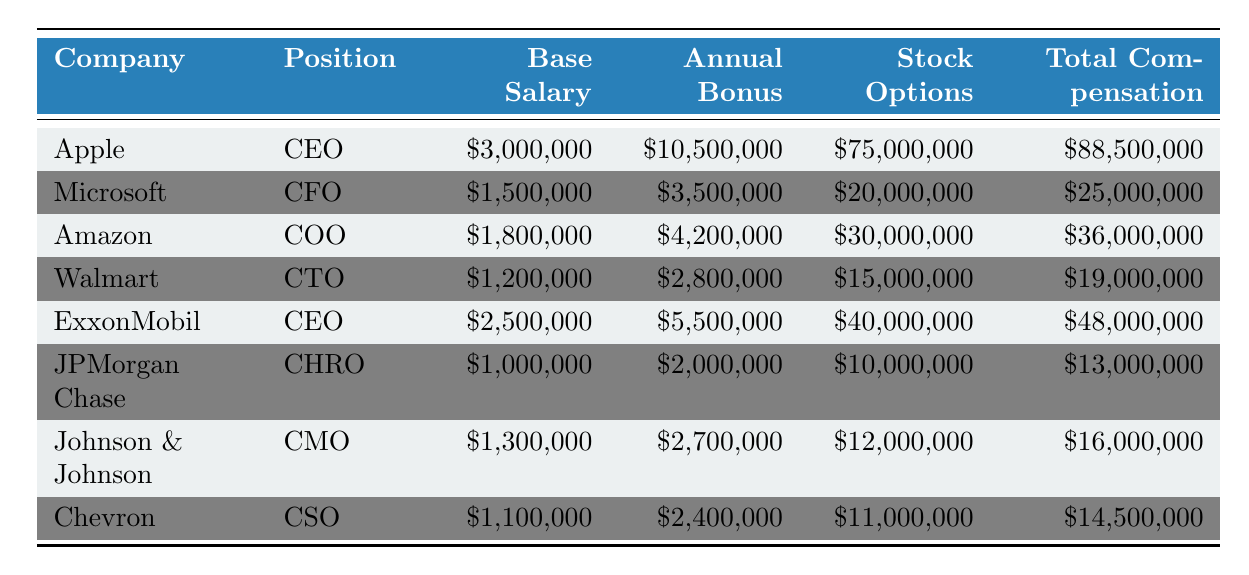What is the total compensation for the CEO of Apple? The table lists the CEO of Apple with a total compensation of $88,500,000.
Answer: $88,500,000 Which executive position has the highest base salary? Reviewing the base salaries, Apple's CEO has the highest at $3,000,000.
Answer: CEO of Apple True or False: The CEO of ExxonMobil has a higher total compensation than the CEO of Apple. The total compensation for the CEO of ExxonMobil is $48,000,000, which is less than Apple's $88,500,000. Thus, the statement is false.
Answer: False What is the average base salary of the executives listed? Adding the base salaries ($3,000,000 + $1,500,000 + $1,800,000 + $1,200,000 + $2,500,000 + $1,000,000 + $1,300,000 + $1,100,000) gives $12,400,000. There are 8 executives, so the average is $12,400,000 / 8 = $1,550,000.
Answer: $1,550,000 Which company offers the least stock options? Looking at the stock options provided, Chevron offers the least at $11,000,000.
Answer: Chevron What is the difference between the total compensation of the CEO of Apple and the CFO of Microsoft? The CEO of Apple has a total compensation of $88,500,000, while the CFO of Microsoft has $25,000,000. The difference is $88,500,000 - $25,000,000 = $63,500,000.
Answer: $63,500,000 True or False: The total compensation for the CHRO of JPMorgan Chase is lower than $15,000,000. The total compensation for the CHRO of JPMorgan Chase is $13,000,000, which is indeed lower than $15,000,000. So, the statement is true.
Answer: True What is the highest annual bonus among the executives? In reviewing the annual bonuses, the highest bonus is $10,500,000 received by the CEO of Apple.
Answer: $10,500,000 